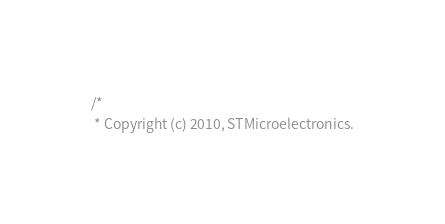<code> <loc_0><loc_0><loc_500><loc_500><_C_>/*
 * Copyright (c) 2010, STMicroelectronics.</code> 